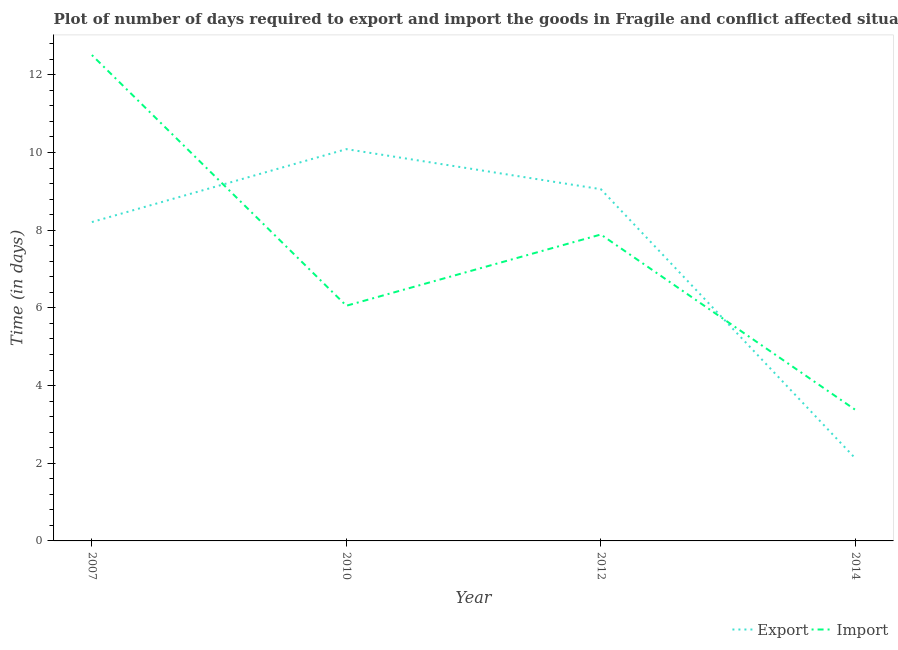How many different coloured lines are there?
Your answer should be very brief. 2. What is the time required to import in 2010?
Your response must be concise. 6.05. Across all years, what is the maximum time required to export?
Give a very brief answer. 10.09. Across all years, what is the minimum time required to export?
Offer a terse response. 2.12. In which year was the time required to import minimum?
Ensure brevity in your answer.  2014. What is the total time required to export in the graph?
Provide a short and direct response. 29.48. What is the difference between the time required to export in 2007 and that in 2014?
Your answer should be compact. 6.08. What is the difference between the time required to import in 2012 and the time required to export in 2014?
Make the answer very short. 5.76. What is the average time required to import per year?
Give a very brief answer. 7.46. In the year 2010, what is the difference between the time required to import and time required to export?
Your answer should be compact. -4.03. In how many years, is the time required to export greater than 1.6 days?
Offer a terse response. 4. What is the ratio of the time required to import in 2012 to that in 2014?
Give a very brief answer. 2.34. What is the difference between the highest and the second highest time required to import?
Make the answer very short. 4.62. What is the difference between the highest and the lowest time required to export?
Keep it short and to the point. 7.96. In how many years, is the time required to export greater than the average time required to export taken over all years?
Your answer should be very brief. 3. Does the time required to import monotonically increase over the years?
Ensure brevity in your answer.  No. Is the time required to export strictly less than the time required to import over the years?
Your answer should be very brief. No. Are the values on the major ticks of Y-axis written in scientific E-notation?
Offer a very short reply. No. Does the graph contain any zero values?
Offer a terse response. No. How many legend labels are there?
Your answer should be very brief. 2. How are the legend labels stacked?
Your response must be concise. Horizontal. What is the title of the graph?
Your response must be concise. Plot of number of days required to export and import the goods in Fragile and conflict affected situations. Does "current US$" appear as one of the legend labels in the graph?
Provide a succinct answer. No. What is the label or title of the X-axis?
Ensure brevity in your answer.  Year. What is the label or title of the Y-axis?
Provide a succinct answer. Time (in days). What is the Time (in days) in Export in 2007?
Your answer should be compact. 8.21. What is the Time (in days) in Import in 2007?
Offer a very short reply. 12.51. What is the Time (in days) in Export in 2010?
Offer a very short reply. 10.09. What is the Time (in days) of Import in 2010?
Offer a terse response. 6.05. What is the Time (in days) of Export in 2012?
Give a very brief answer. 9.06. What is the Time (in days) of Import in 2012?
Give a very brief answer. 7.89. What is the Time (in days) of Export in 2014?
Your response must be concise. 2.12. What is the Time (in days) of Import in 2014?
Provide a short and direct response. 3.38. Across all years, what is the maximum Time (in days) in Export?
Make the answer very short. 10.09. Across all years, what is the maximum Time (in days) in Import?
Your answer should be compact. 12.51. Across all years, what is the minimum Time (in days) in Export?
Your answer should be very brief. 2.12. Across all years, what is the minimum Time (in days) in Import?
Your answer should be compact. 3.38. What is the total Time (in days) of Export in the graph?
Offer a very short reply. 29.48. What is the total Time (in days) in Import in the graph?
Make the answer very short. 29.83. What is the difference between the Time (in days) of Export in 2007 and that in 2010?
Your answer should be compact. -1.88. What is the difference between the Time (in days) of Import in 2007 and that in 2010?
Your response must be concise. 6.45. What is the difference between the Time (in days) of Export in 2007 and that in 2012?
Provide a succinct answer. -0.85. What is the difference between the Time (in days) of Import in 2007 and that in 2012?
Offer a terse response. 4.62. What is the difference between the Time (in days) of Export in 2007 and that in 2014?
Ensure brevity in your answer.  6.08. What is the difference between the Time (in days) in Import in 2007 and that in 2014?
Provide a succinct answer. 9.13. What is the difference between the Time (in days) in Export in 2010 and that in 2012?
Offer a very short reply. 1.03. What is the difference between the Time (in days) in Import in 2010 and that in 2012?
Your response must be concise. -1.83. What is the difference between the Time (in days) in Export in 2010 and that in 2014?
Provide a succinct answer. 7.96. What is the difference between the Time (in days) of Import in 2010 and that in 2014?
Give a very brief answer. 2.68. What is the difference between the Time (in days) of Export in 2012 and that in 2014?
Ensure brevity in your answer.  6.93. What is the difference between the Time (in days) in Import in 2012 and that in 2014?
Provide a short and direct response. 4.51. What is the difference between the Time (in days) in Export in 2007 and the Time (in days) in Import in 2010?
Your answer should be very brief. 2.15. What is the difference between the Time (in days) of Export in 2007 and the Time (in days) of Import in 2012?
Provide a short and direct response. 0.32. What is the difference between the Time (in days) in Export in 2007 and the Time (in days) in Import in 2014?
Offer a terse response. 4.83. What is the difference between the Time (in days) of Export in 2010 and the Time (in days) of Import in 2012?
Your answer should be compact. 2.2. What is the difference between the Time (in days) in Export in 2010 and the Time (in days) in Import in 2014?
Your response must be concise. 6.71. What is the difference between the Time (in days) of Export in 2012 and the Time (in days) of Import in 2014?
Offer a terse response. 5.68. What is the average Time (in days) in Export per year?
Your response must be concise. 7.37. What is the average Time (in days) of Import per year?
Your answer should be compact. 7.46. In the year 2007, what is the difference between the Time (in days) of Export and Time (in days) of Import?
Keep it short and to the point. -4.3. In the year 2010, what is the difference between the Time (in days) in Export and Time (in days) in Import?
Offer a very short reply. 4.03. In the year 2014, what is the difference between the Time (in days) in Export and Time (in days) in Import?
Give a very brief answer. -1.25. What is the ratio of the Time (in days) of Export in 2007 to that in 2010?
Provide a succinct answer. 0.81. What is the ratio of the Time (in days) in Import in 2007 to that in 2010?
Provide a short and direct response. 2.07. What is the ratio of the Time (in days) in Export in 2007 to that in 2012?
Make the answer very short. 0.91. What is the ratio of the Time (in days) of Import in 2007 to that in 2012?
Offer a terse response. 1.59. What is the ratio of the Time (in days) of Export in 2007 to that in 2014?
Provide a short and direct response. 3.86. What is the ratio of the Time (in days) in Import in 2007 to that in 2014?
Your answer should be very brief. 3.71. What is the ratio of the Time (in days) in Export in 2010 to that in 2012?
Give a very brief answer. 1.11. What is the ratio of the Time (in days) of Import in 2010 to that in 2012?
Provide a succinct answer. 0.77. What is the ratio of the Time (in days) of Export in 2010 to that in 2014?
Offer a terse response. 4.75. What is the ratio of the Time (in days) of Import in 2010 to that in 2014?
Make the answer very short. 1.79. What is the ratio of the Time (in days) of Export in 2012 to that in 2014?
Ensure brevity in your answer.  4.26. What is the ratio of the Time (in days) in Import in 2012 to that in 2014?
Give a very brief answer. 2.34. What is the difference between the highest and the second highest Time (in days) in Export?
Your answer should be very brief. 1.03. What is the difference between the highest and the second highest Time (in days) in Import?
Offer a terse response. 4.62. What is the difference between the highest and the lowest Time (in days) in Export?
Keep it short and to the point. 7.96. What is the difference between the highest and the lowest Time (in days) of Import?
Ensure brevity in your answer.  9.13. 